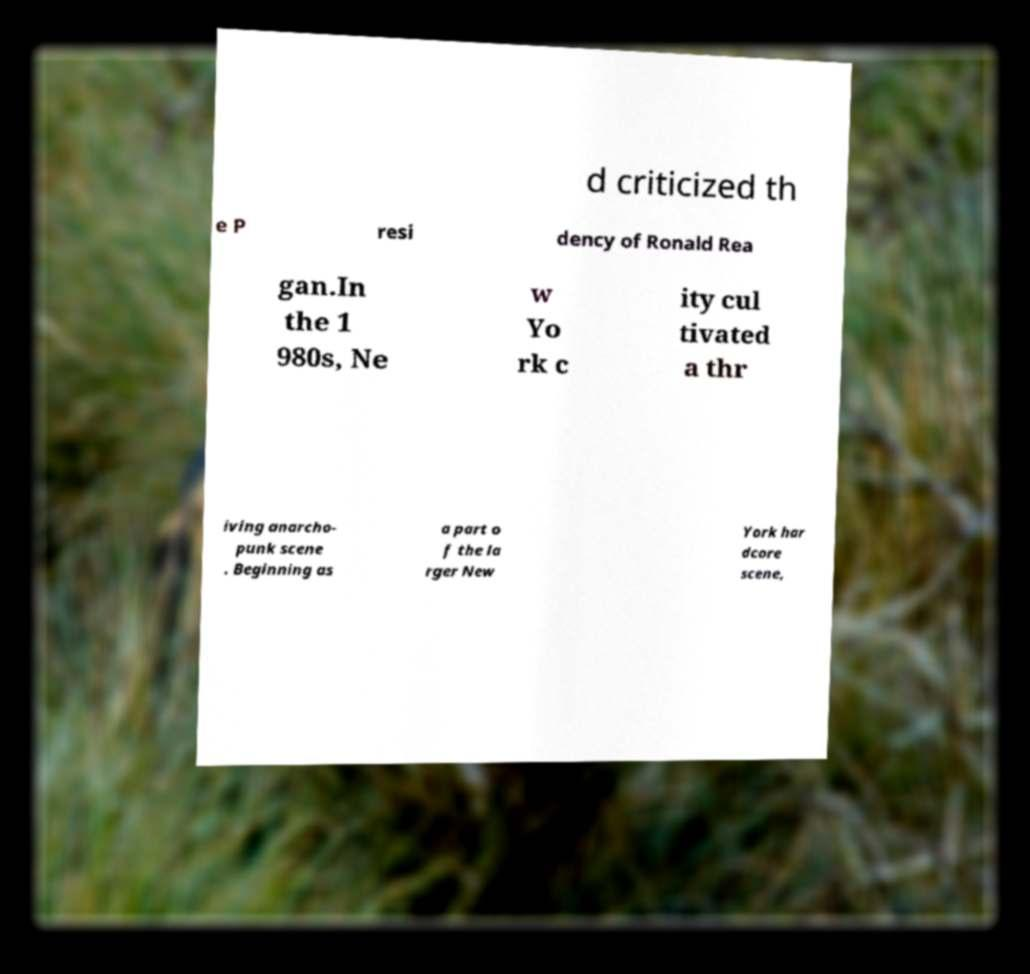Please read and relay the text visible in this image. What does it say? d criticized th e P resi dency of Ronald Rea gan.In the 1 980s, Ne w Yo rk c ity cul tivated a thr iving anarcho- punk scene . Beginning as a part o f the la rger New York har dcore scene, 